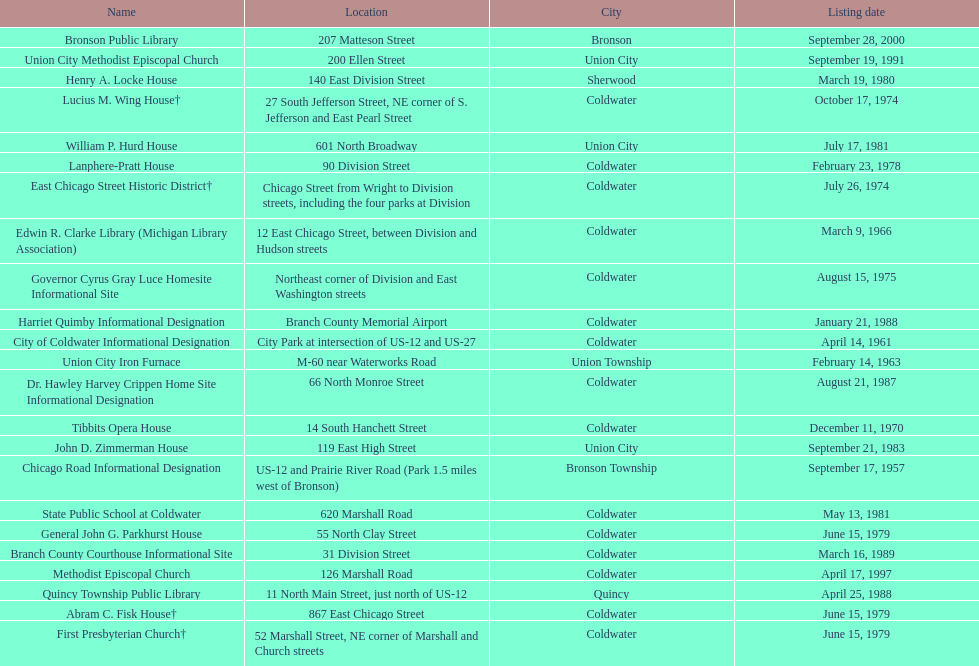How many historic sites are listed in coldwater? 15. 